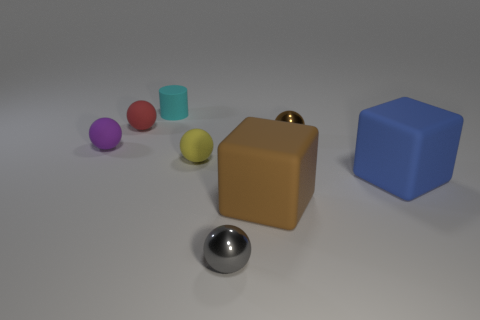Is there a cube of the same color as the matte cylinder?
Your answer should be very brief. No. What number of other things are the same material as the big blue block?
Make the answer very short. 5. There is a rubber cylinder; is it the same color as the rubber sphere on the right side of the cylinder?
Ensure brevity in your answer.  No. Are there more purple rubber balls that are behind the red sphere than big cubes?
Offer a very short reply. No. What number of brown rubber things are on the right side of the rubber object that is on the right side of the brown object in front of the blue block?
Your response must be concise. 0. There is a tiny shiny thing that is right of the gray sphere; is its shape the same as the cyan thing?
Your response must be concise. No. There is a tiny ball left of the red thing; what material is it?
Provide a succinct answer. Rubber. The small matte object that is both in front of the tiny brown metallic object and on the right side of the purple rubber thing has what shape?
Ensure brevity in your answer.  Sphere. What is the material of the small cyan thing?
Your response must be concise. Rubber. What number of balls are tiny gray metallic things or purple rubber objects?
Your answer should be very brief. 2. 